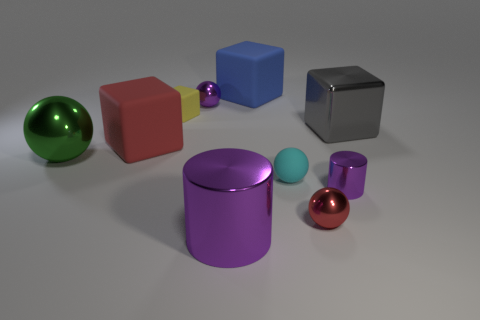How many objects in the image are reflective? Four objects in the image show reflective surfaces: the green sphere, the purple cylinder, the red sphere, and the small blue cube. 